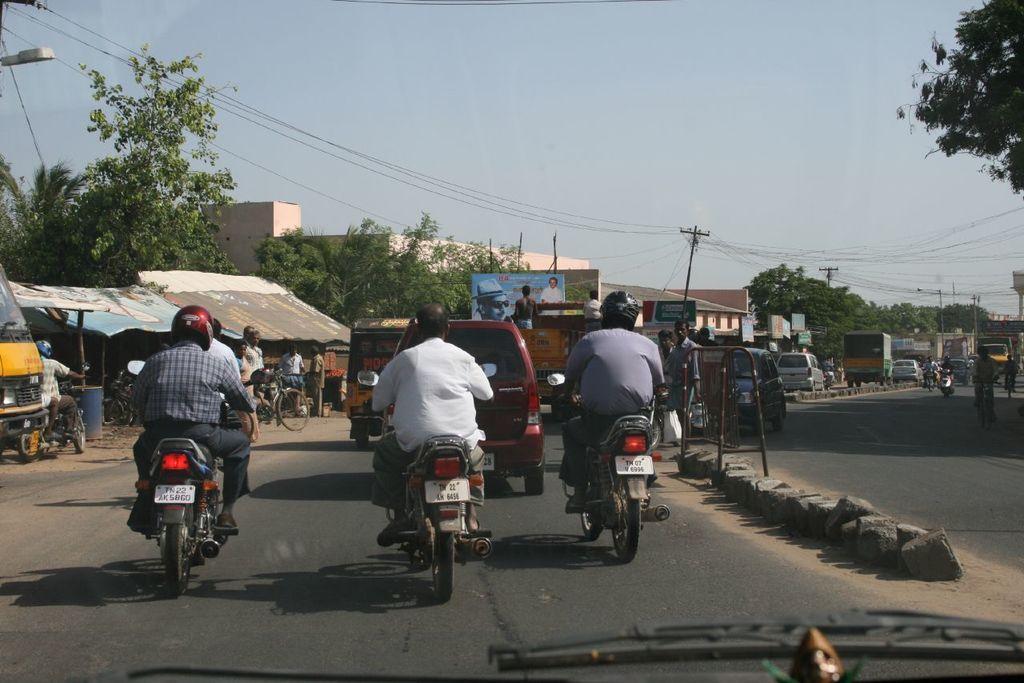Please provide a concise description of this image. In the middle of the image few persons are going on a vehicle on the road and there are some buildings and trees. Top of the image there is a sky. 